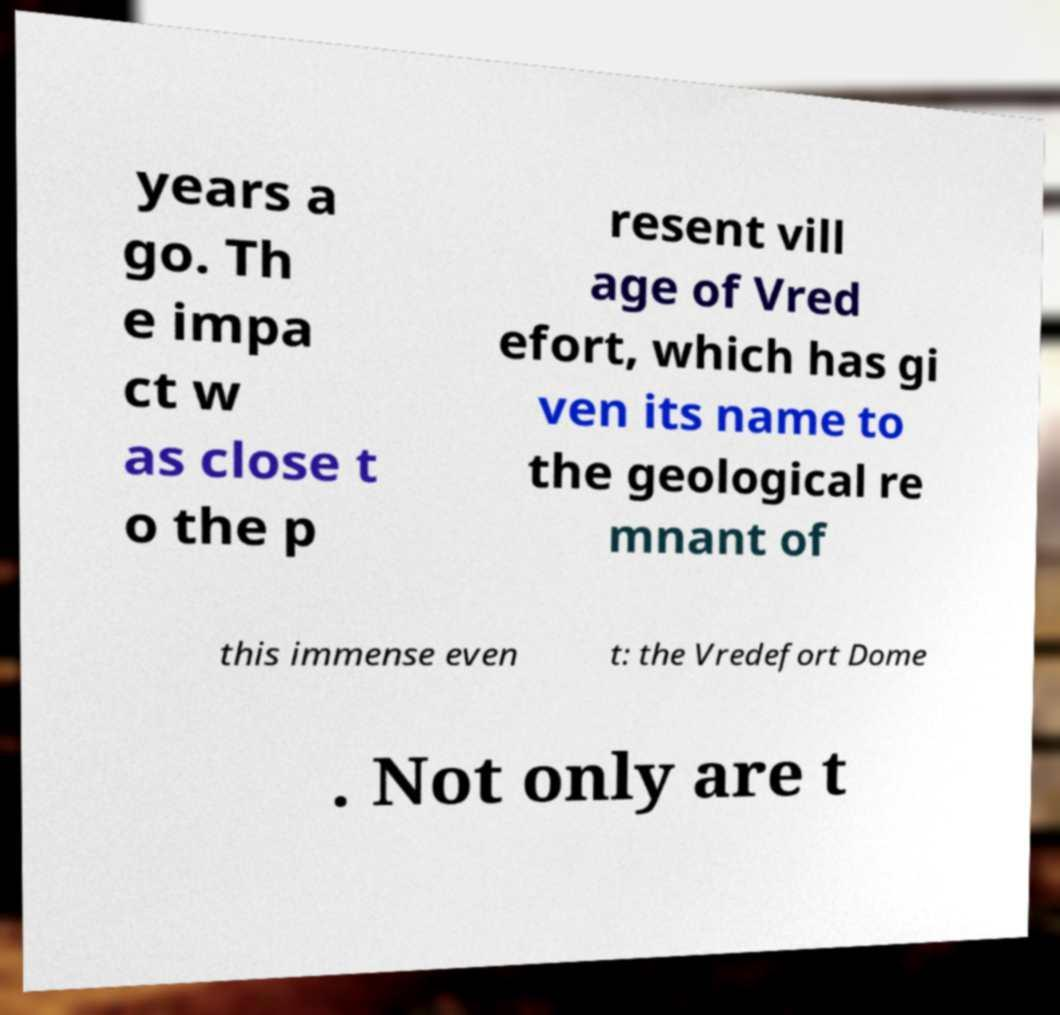Could you assist in decoding the text presented in this image and type it out clearly? years a go. Th e impa ct w as close t o the p resent vill age of Vred efort, which has gi ven its name to the geological re mnant of this immense even t: the Vredefort Dome . Not only are t 